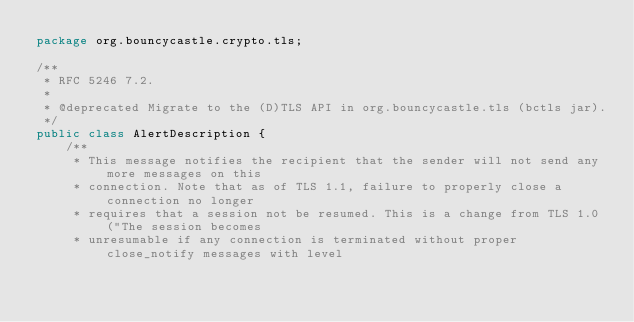Convert code to text. <code><loc_0><loc_0><loc_500><loc_500><_Java_>package org.bouncycastle.crypto.tls;

/**
 * RFC 5246 7.2.
 *
 * @deprecated Migrate to the (D)TLS API in org.bouncycastle.tls (bctls jar).
 */
public class AlertDescription {
    /**
     * This message notifies the recipient that the sender will not send any more messages on this
     * connection. Note that as of TLS 1.1, failure to properly close a connection no longer
     * requires that a session not be resumed. This is a change from TLS 1.0 ("The session becomes
     * unresumable if any connection is terminated without proper close_notify messages with level</code> 